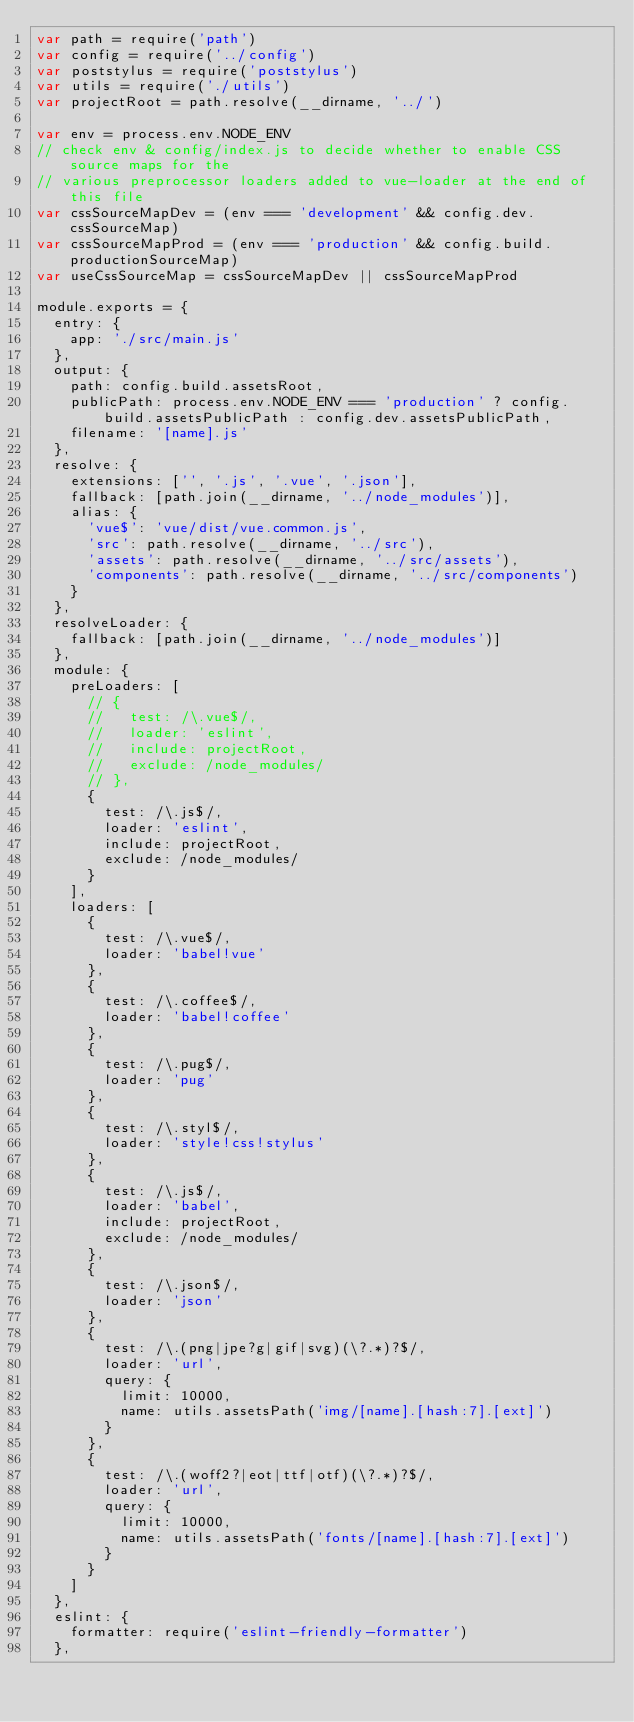Convert code to text. <code><loc_0><loc_0><loc_500><loc_500><_JavaScript_>var path = require('path')
var config = require('../config')
var poststylus = require('poststylus')
var utils = require('./utils')
var projectRoot = path.resolve(__dirname, '../')

var env = process.env.NODE_ENV
// check env & config/index.js to decide whether to enable CSS source maps for the
// various preprocessor loaders added to vue-loader at the end of this file
var cssSourceMapDev = (env === 'development' && config.dev.cssSourceMap)
var cssSourceMapProd = (env === 'production' && config.build.productionSourceMap)
var useCssSourceMap = cssSourceMapDev || cssSourceMapProd

module.exports = {
  entry: {
    app: './src/main.js'
  },
  output: {
    path: config.build.assetsRoot,
    publicPath: process.env.NODE_ENV === 'production' ? config.build.assetsPublicPath : config.dev.assetsPublicPath,
    filename: '[name].js'
  },
  resolve: {
    extensions: ['', '.js', '.vue', '.json'],
    fallback: [path.join(__dirname, '../node_modules')],
    alias: {
      'vue$': 'vue/dist/vue.common.js',
      'src': path.resolve(__dirname, '../src'),
      'assets': path.resolve(__dirname, '../src/assets'),
      'components': path.resolve(__dirname, '../src/components')
    }
  },
  resolveLoader: {
    fallback: [path.join(__dirname, '../node_modules')]
  },
  module: {
    preLoaders: [
      // {
      //   test: /\.vue$/,
      //   loader: 'eslint',
      //   include: projectRoot,
      //   exclude: /node_modules/
      // },
      {
        test: /\.js$/,
        loader: 'eslint',
        include: projectRoot,
        exclude: /node_modules/
      }
    ],
    loaders: [
      {
        test: /\.vue$/,
        loader: 'babel!vue'
      },
      {
        test: /\.coffee$/,
        loader: 'babel!coffee'
      },
      {
        test: /\.pug$/,
        loader: 'pug'
      },
      {
        test: /\.styl$/,
        loader: 'style!css!stylus'
      },
      {
        test: /\.js$/,
        loader: 'babel',
        include: projectRoot,
        exclude: /node_modules/
      },
      {
        test: /\.json$/,
        loader: 'json'
      },
      {
        test: /\.(png|jpe?g|gif|svg)(\?.*)?$/,
        loader: 'url',
        query: {
          limit: 10000,
          name: utils.assetsPath('img/[name].[hash:7].[ext]')
        }
      },
      {
        test: /\.(woff2?|eot|ttf|otf)(\?.*)?$/,
        loader: 'url',
        query: {
          limit: 10000,
          name: utils.assetsPath('fonts/[name].[hash:7].[ext]')
        }
      }
    ]
  },
  eslint: {
    formatter: require('eslint-friendly-formatter')
  },</code> 